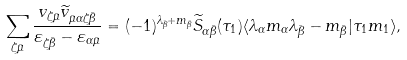Convert formula to latex. <formula><loc_0><loc_0><loc_500><loc_500>\sum _ { \zeta \bar { \mu } } \frac { v _ { \zeta \bar { \mu } } \widetilde { v } _ { \bar { \mu } \alpha \zeta \bar { \beta } } } { \varepsilon _ { \zeta \bar { \beta } } - \varepsilon _ { \alpha \bar { \mu } } } = ( - 1 ) ^ { \lambda _ { \bar { \beta } } + m _ { \bar { \beta } } } \widetilde { S } _ { \alpha \bar { \beta } } ( \tau _ { 1 } ) \langle \lambda _ { \alpha } m _ { \alpha } \lambda _ { \bar { \beta } } - m _ { \bar { \beta } } | \tau _ { 1 } m _ { 1 } \rangle ,</formula> 